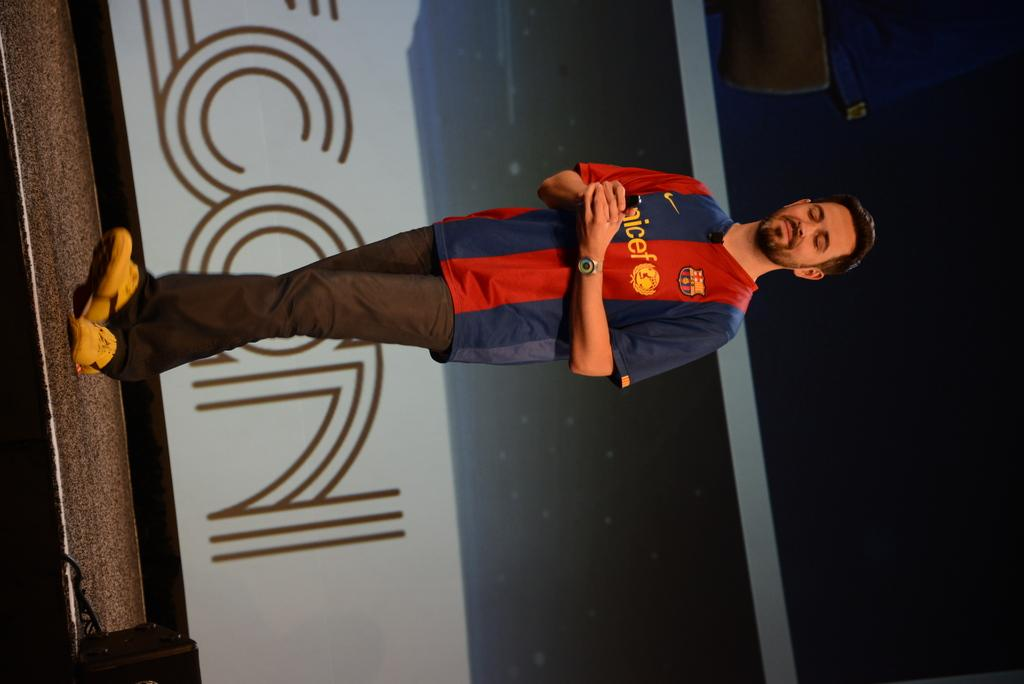What is the main subject of the image? There is a person walking on the stage in the image. What can be seen in the background of the image? There is a banner in the background of the image. How would you describe the lighting in the image? The right side of the image appears to be dark. What type of pencil is being used by the person on stage in the image? There is no pencil visible in the image, as the main subject is a person walking on the stage. 